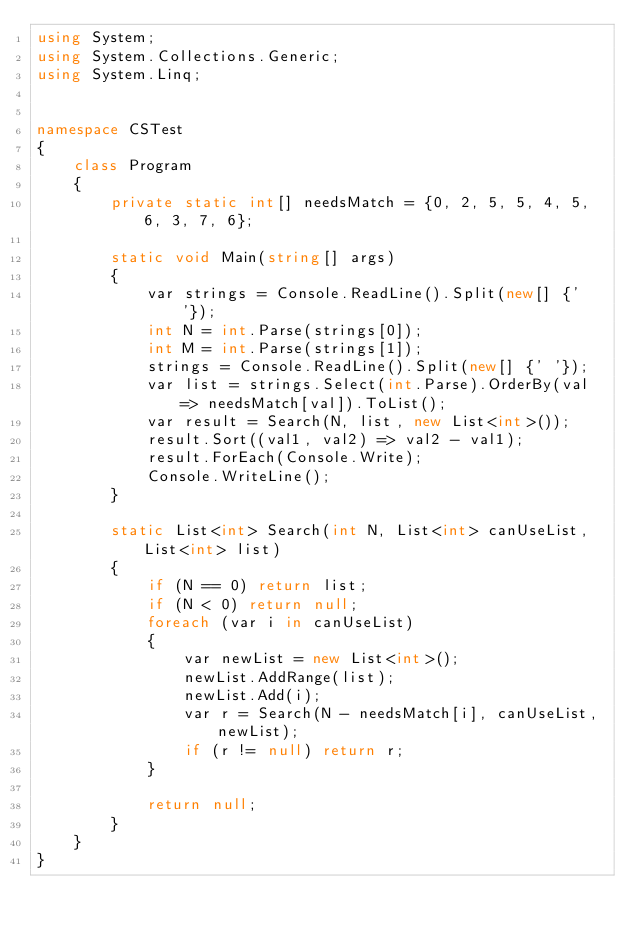Convert code to text. <code><loc_0><loc_0><loc_500><loc_500><_C#_>using System;
using System.Collections.Generic;
using System.Linq;


namespace CSTest
{
    class Program
    {
        private static int[] needsMatch = {0, 2, 5, 5, 4, 5, 6, 3, 7, 6};

        static void Main(string[] args)
        {
            var strings = Console.ReadLine().Split(new[] {' '});
            int N = int.Parse(strings[0]);
            int M = int.Parse(strings[1]);
            strings = Console.ReadLine().Split(new[] {' '});
            var list = strings.Select(int.Parse).OrderBy(val => needsMatch[val]).ToList();
            var result = Search(N, list, new List<int>());
            result.Sort((val1, val2) => val2 - val1);
            result.ForEach(Console.Write);
            Console.WriteLine();
        }

        static List<int> Search(int N, List<int> canUseList, List<int> list)
        {
            if (N == 0) return list;
            if (N < 0) return null;
            foreach (var i in canUseList)
            {
                var newList = new List<int>();
                newList.AddRange(list);
                newList.Add(i);
                var r = Search(N - needsMatch[i], canUseList, newList);
                if (r != null) return r;
            }

            return null;
        }
    }
}</code> 